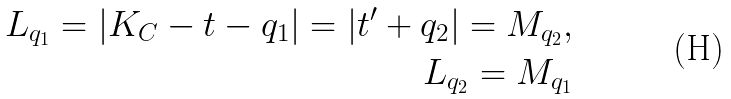Convert formula to latex. <formula><loc_0><loc_0><loc_500><loc_500>L _ { q _ { 1 } } = | K _ { C } - t - q _ { 1 } | = | t ^ { \prime } + q _ { 2 } | = M _ { q _ { 2 } } , \\ L _ { q _ { 2 } } = M _ { q _ { 1 } }</formula> 